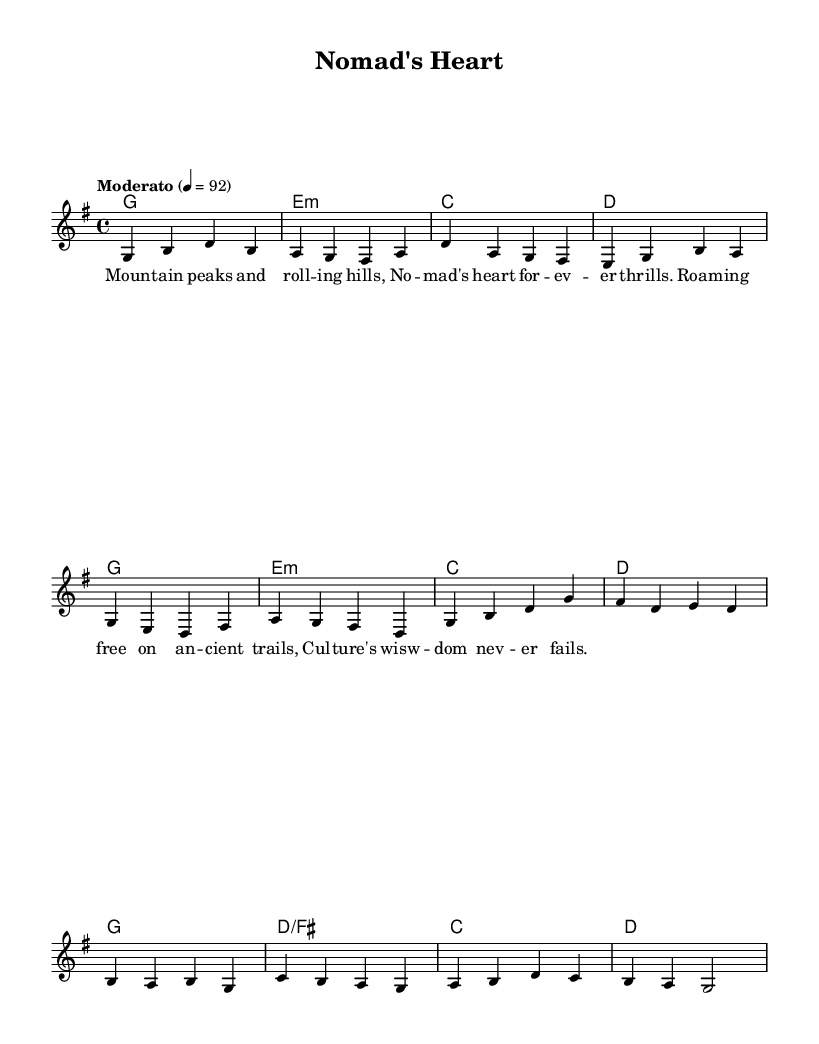What is the key signature of this music? The key signature is G major, which has one sharp (F#). This can be identified by looking at the beginning of the staff where the key signature is indicated.
Answer: G major What is the time signature of this piece? The time signature is 4/4, indicated at the beginning of the sheet music. This means four beats per measure and a quarter note gets one beat.
Answer: 4/4 What is the tempo marking for this music? The tempo marking is "Moderato" at a speed of 92 beats per minute, which is specified in the score.
Answer: Moderato, 92 How many measures are in the verse section? The verse section consists of 6 measures. By counting the groups of notes separated by vertical lines, one can determine the number of measures.
Answer: 6 What type of musical form is observed in this piece? The piece exhibits a verse-chorus form, as it contains distinct sections labeled as "Verse" and "Chorus" that alternate. This is characteristic of pop ballads.
Answer: Verse-Chorus What is the key change in the chorus section? There are no key changes in the chorus; it remains in G major throughout both the verse and the chorus. This can be understood by looking at the harmony indicated for both sections.
Answer: No key change What emotion does the lyrics convey according to the theme? The lyrics convey a sense of freedom and adventure, highlighting the nomadic lifestyle and the connection to the mountains, which is reflected in the imagery used.
Answer: Freedom and adventure 